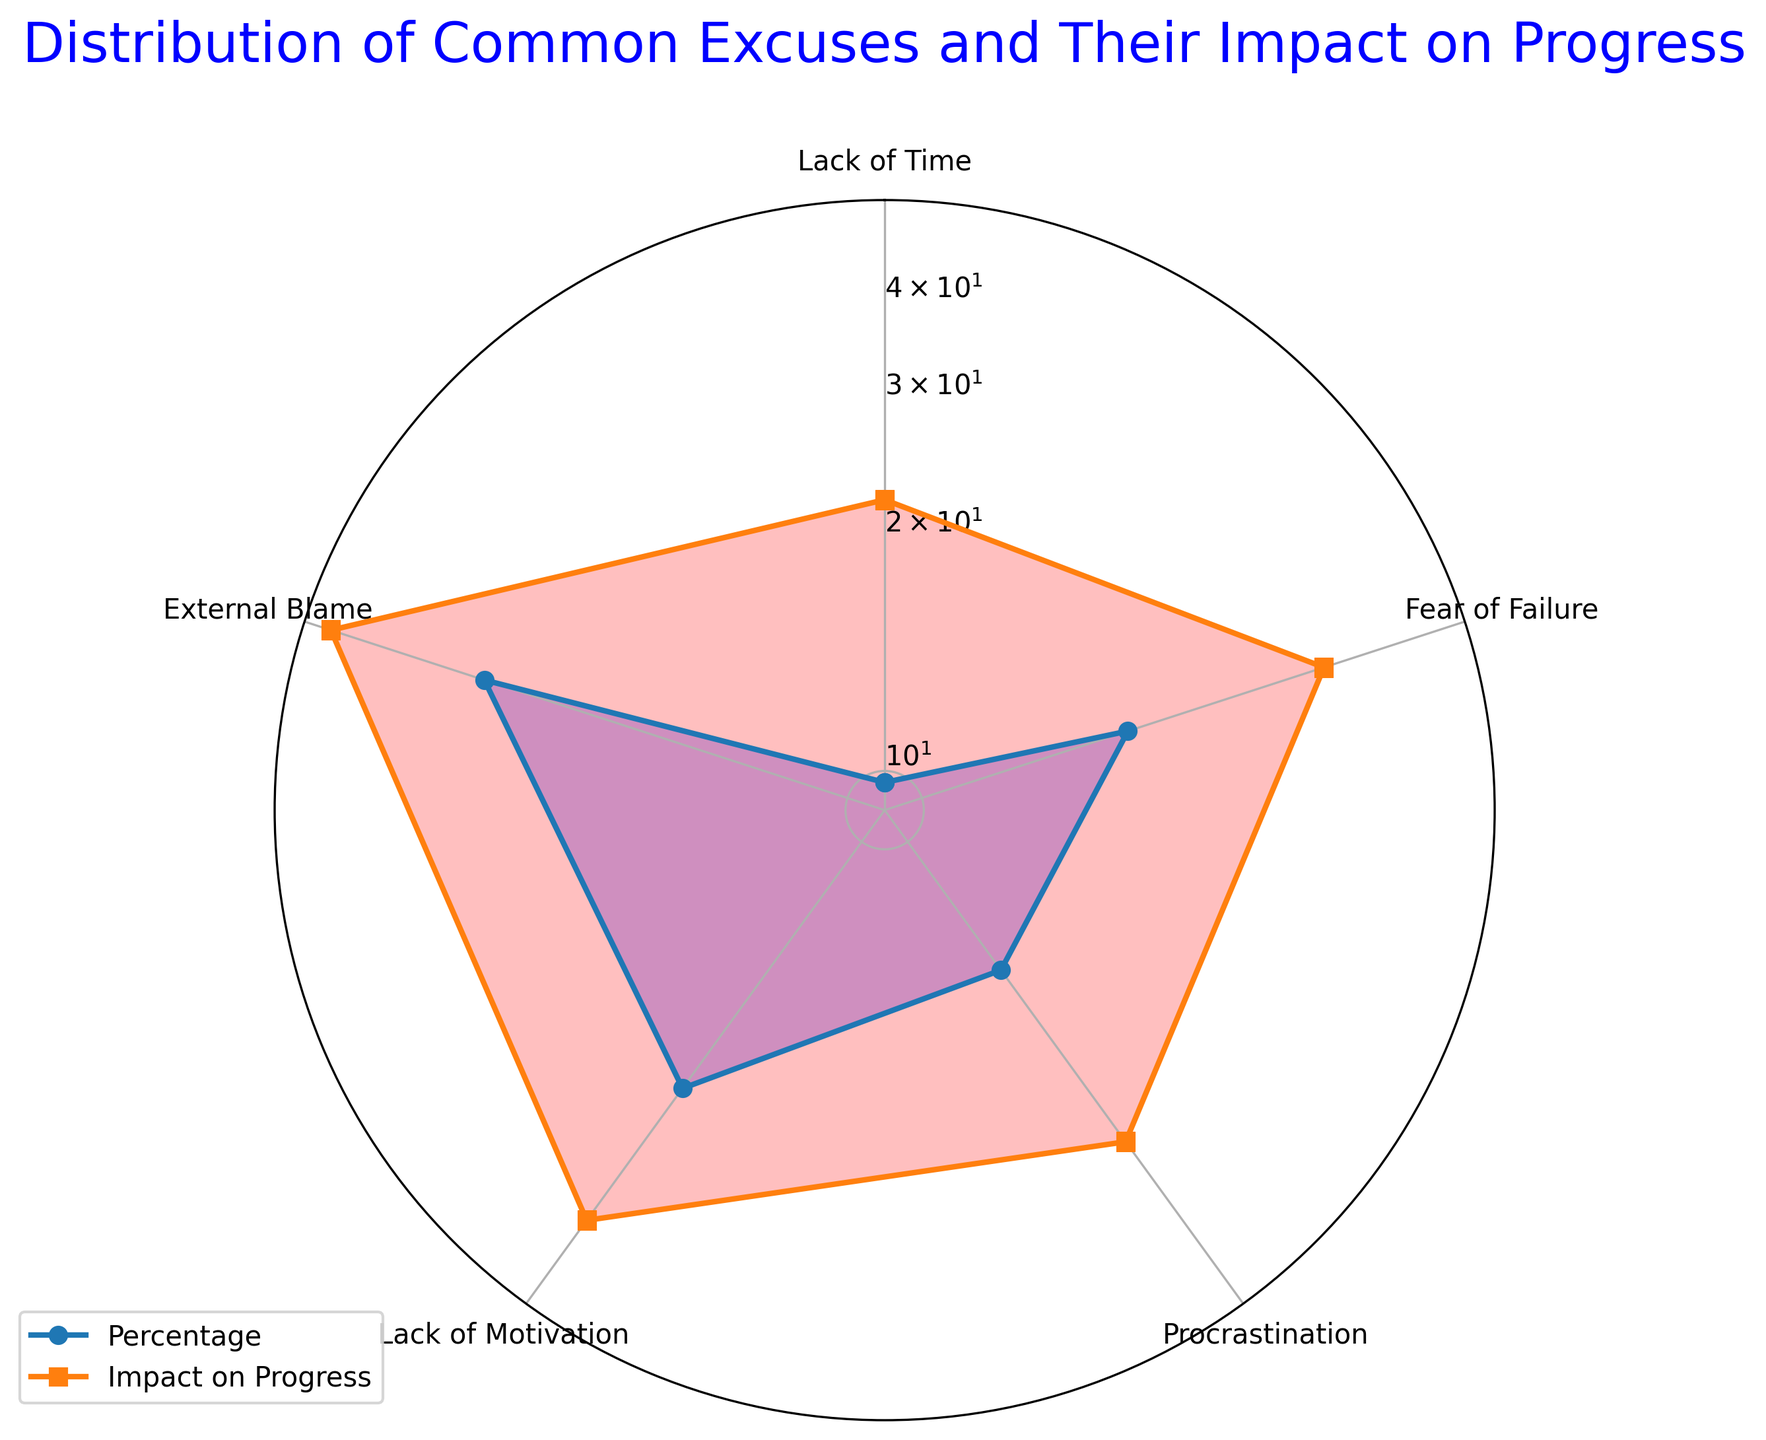What's the average impact on progress for Lack of Motivation and Procrastination? First, note the average impact on progress for both categories from the chart. Lack of Motivation has an average impact of 30, while Procrastination has an average impact of 50. Adding these values gives 30 + 50 = 80. Dividing by 2 (the number of categories) gives 80 / 2 = 40.
Answer: 40 Which excuse has the highest percentage and what is its value? Identify the category with the highest value among the percentages. From the chart, Procrastination has the highest average percentage value of 31.
Answer: Procrastination, 31 Which excuse has the lowest impact on progress and what is its value? Look at the average impact values for all categories and find the lowest value. External Blame has the lowest impact on progress with a value of 22.
Answer: External Blame, 22 Is the impact on progress for Procrastination higher or lower than Fear of Failure? From the chart, the impact on progress for Procrastination is 50, while for Fear of Failure it is 35. Since 50 is greater than 35, Procrastination has a higher impact on progress.
Answer: Higher Sum the average percentage values of External Blame, Lack of Motivation, and Lack of Time. The average percentages are 10 for External Blame, 16 for Lack of Motivation, and 25 for Lack of Time. Add these values together: 10 + 16 + 25 = 51.
Answer: 51 Compare the percentage values for Lack of Time and Lack of Motivation. Which is higher and by how much? The percentage for Lack of Time is 25, while for Lack of Motivation it is 16. The difference is 25 - 16 = 9. Lack of Time has a higher percentage by 9.
Answer: Lack of Time by 9 Is the average impact on progress for Lack of Time above or below the average impact on progress for Lack of Motivation? The average impact on progress for Lack of Time is 40, while for Lack of Motivation it is 30. Since 40 is greater than 30, Lack of Time's impact on progress is above that of Lack of Motivation.
Answer: Above 